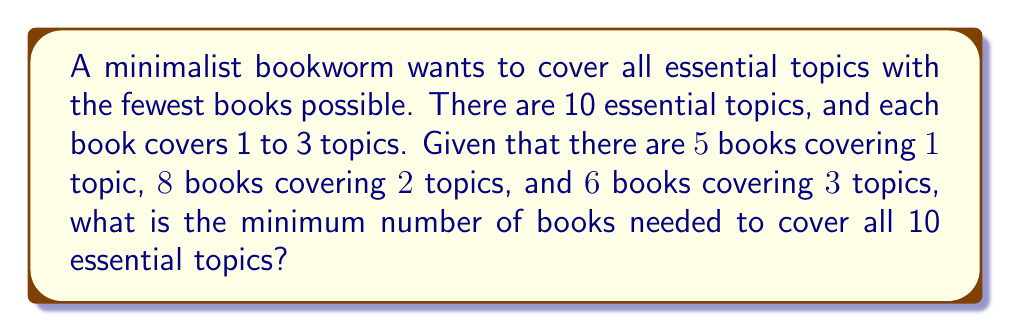Solve this math problem. Let's approach this step-by-step:

1) First, we need to maximize the coverage of topics per book. We'll start with books covering 3 topics each.

2) Let $x$ be the number of 3-topic books, $y$ be the number of 2-topic books, and $z$ be the number of 1-topic books.

3) We need to satisfy the following inequality:

   $$3x + 2y + z \geq 10$$

4) To minimize the total number of books, we'll use as many 3-topic books as possible:

   $$3 \cdot 3 = 9$$ topics can be covered with 3 books

5) We still need to cover 1 more topic, which can be done with a 1-topic book.

6) Therefore, the minimum number of books needed is:

   $$3 + 1 = 4$$ books

7) We can verify that this solution is possible given the available books:
   - We need 3 books covering 3 topics each, and we have 6 available.
   - We need 1 book covering 1 topic, and we have 5 available.

8) This solution minimizes the total number of books while covering all 10 essential topics.
Answer: 4 books 